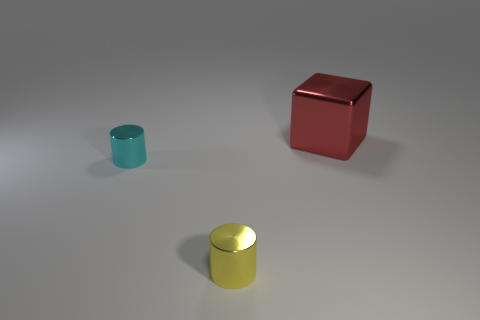There is a thing behind the tiny cylinder that is to the left of the yellow shiny cylinder; what is its shape?
Offer a very short reply. Cube. What number of brown things are big blocks or tiny metallic things?
Offer a terse response. 0. Are there any big red shiny objects to the left of the metallic object that is left of the tiny cylinder on the right side of the cyan metal thing?
Keep it short and to the point. No. Is there anything else that has the same material as the cube?
Provide a short and direct response. Yes. How many large things are cubes or blue matte cubes?
Keep it short and to the point. 1. There is a thing that is in front of the cyan metallic cylinder; is its shape the same as the large thing?
Offer a very short reply. No. Is the number of large brown shiny objects less than the number of tiny yellow shiny cylinders?
Make the answer very short. Yes. Are there any other things that are the same color as the cube?
Offer a terse response. No. What shape is the object that is right of the small yellow cylinder?
Provide a short and direct response. Cube. There is a large object; is it the same color as the tiny metal thing that is in front of the small cyan metal object?
Provide a short and direct response. No. 